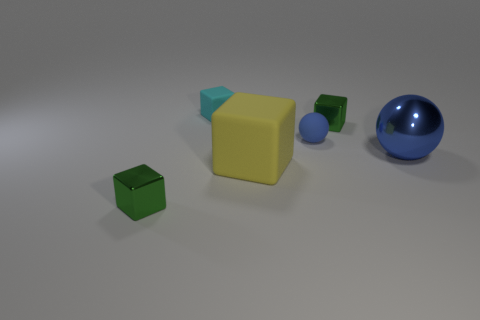Subtract all small cubes. How many cubes are left? 1 Subtract all gray cylinders. How many green blocks are left? 2 Add 3 cyan cubes. How many objects exist? 9 Subtract all yellow blocks. How many blocks are left? 3 Subtract all spheres. How many objects are left? 4 Subtract all blue blocks. Subtract all yellow balls. How many blocks are left? 4 Add 1 large yellow things. How many large yellow things are left? 2 Add 3 tiny blue matte objects. How many tiny blue matte objects exist? 4 Subtract 0 gray cylinders. How many objects are left? 6 Subtract all big cyan rubber balls. Subtract all tiny cyan objects. How many objects are left? 5 